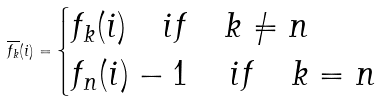Convert formula to latex. <formula><loc_0><loc_0><loc_500><loc_500>\overline { f _ { k } } ( i ) = \begin{cases} f _ { k } ( i ) \quad i f \quad k \neq n \\ f _ { n } ( i ) - 1 \quad \, i f \quad k = n \end{cases}</formula> 